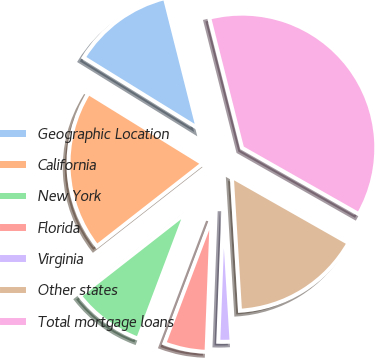Convert chart to OTSL. <chart><loc_0><loc_0><loc_500><loc_500><pie_chart><fcel>Geographic Location<fcel>California<fcel>New York<fcel>Florida<fcel>Virginia<fcel>Other states<fcel>Total mortgage loans<nl><fcel>12.25%<fcel>19.37%<fcel>8.69%<fcel>5.14%<fcel>1.58%<fcel>15.81%<fcel>37.16%<nl></chart> 